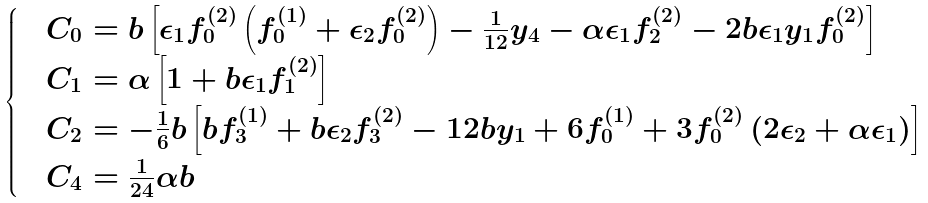<formula> <loc_0><loc_0><loc_500><loc_500>\begin{cases} & C _ { 0 } = b \left [ \epsilon _ { 1 } f _ { 0 } ^ { ( 2 ) } \left ( f _ { 0 } ^ { ( 1 ) } + \epsilon _ { 2 } f _ { 0 } ^ { ( 2 ) } \right ) - \frac { 1 } { 1 2 } y _ { 4 } - \alpha \epsilon _ { 1 } f _ { 2 } ^ { ( 2 ) } - 2 b \epsilon _ { 1 } y _ { 1 } f _ { 0 } ^ { ( 2 ) } \right ] \\ & C _ { 1 } = \alpha \left [ 1 + b \epsilon _ { 1 } f _ { 1 } ^ { ( 2 ) } \right ] \\ & C _ { 2 } = - \frac { 1 } { 6 } b \left [ b f _ { 3 } ^ { ( 1 ) } + b \epsilon _ { 2 } f _ { 3 } ^ { ( 2 ) } - 1 2 b y _ { 1 } + 6 f _ { 0 } ^ { ( 1 ) } + 3 f _ { 0 } ^ { ( 2 ) } \left ( 2 \epsilon _ { 2 } + \alpha \epsilon _ { 1 } \right ) \right ] \\ & C _ { 4 } = \frac { 1 } { 2 4 } \alpha b \end{cases}</formula> 